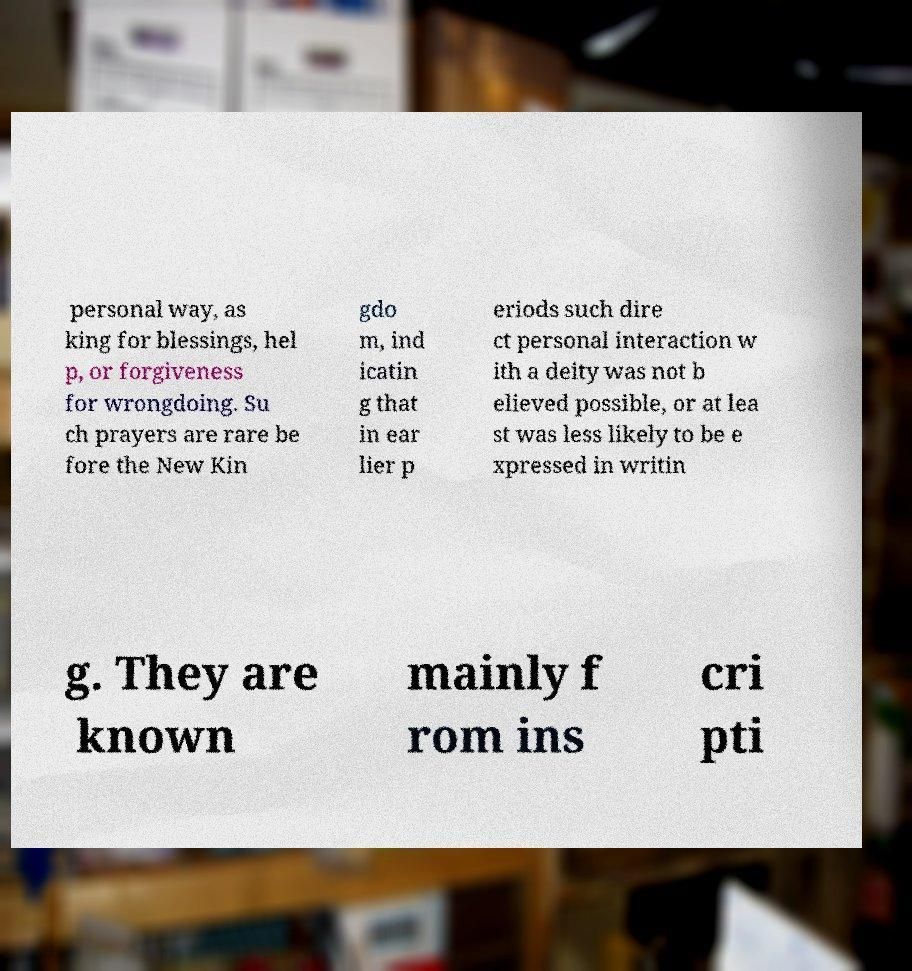There's text embedded in this image that I need extracted. Can you transcribe it verbatim? personal way, as king for blessings, hel p, or forgiveness for wrongdoing. Su ch prayers are rare be fore the New Kin gdo m, ind icatin g that in ear lier p eriods such dire ct personal interaction w ith a deity was not b elieved possible, or at lea st was less likely to be e xpressed in writin g. They are known mainly f rom ins cri pti 